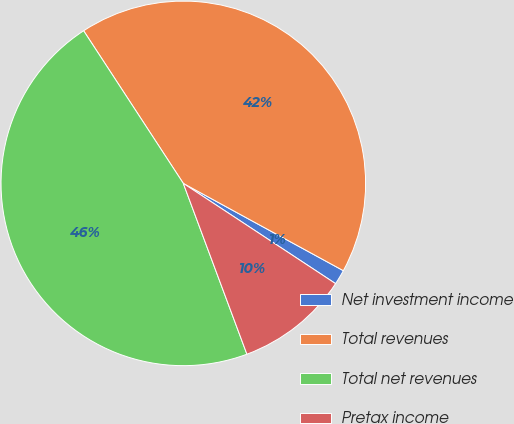Convert chart. <chart><loc_0><loc_0><loc_500><loc_500><pie_chart><fcel>Net investment income<fcel>Total revenues<fcel>Total net revenues<fcel>Pretax income<nl><fcel>1.32%<fcel>42.16%<fcel>46.47%<fcel>10.06%<nl></chart> 